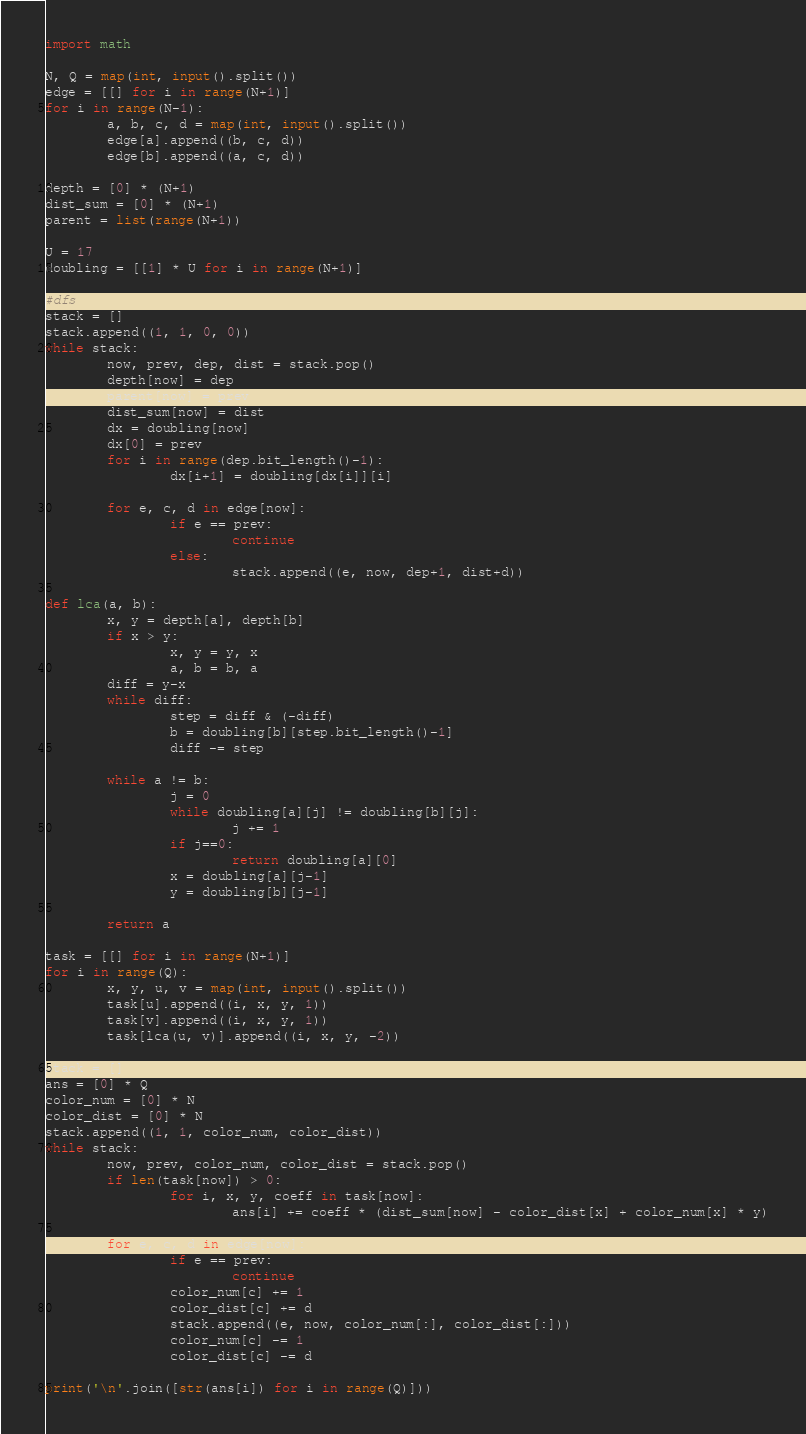Convert code to text. <code><loc_0><loc_0><loc_500><loc_500><_Python_>import math

N, Q = map(int, input().split())
edge = [[] for i in range(N+1)]
for i in range(N-1):
        a, b, c, d = map(int, input().split())
        edge[a].append((b, c, d))
        edge[b].append((a, c, d))

depth = [0] * (N+1)
dist_sum = [0] * (N+1)
parent = list(range(N+1))

U = 17
doubling = [[1] * U for i in range(N+1)]

#dfs
stack = []
stack.append((1, 1, 0, 0))
while stack:
        now, prev, dep, dist = stack.pop()
        depth[now] = dep
        parent[now] = prev
        dist_sum[now] = dist
        dx = doubling[now]
        dx[0] = prev
        for i in range(dep.bit_length()-1):
                dx[i+1] = doubling[dx[i]][i]
        
        for e, c, d in edge[now]:
                if e == prev:
                        continue
                else:
                        stack.append((e, now, dep+1, dist+d))

def lca(a, b):
        x, y = depth[a], depth[b]
        if x > y:
                x, y = y, x
                a, b = b, a        
        diff = y-x
        while diff:
                step = diff & (-diff)
                b = doubling[b][step.bit_length()-1]
                diff -= step

        while a != b:
                j = 0
                while doubling[a][j] != doubling[b][j]:
                        j += 1
                if j==0:
                        return doubling[a][0]
                x = doubling[a][j-1]
                y = doubling[b][j-1]

        return a

task = [[] for i in range(N+1)]
for i in range(Q):
        x, y, u, v = map(int, input().split())
        task[u].append((i, x, y, 1))
        task[v].append((i, x, y, 1))
        task[lca(u, v)].append((i, x, y, -2))

stack = []
ans = [0] * Q
color_num = [0] * N
color_dist = [0] * N
stack.append((1, 1, color_num, color_dist))
while stack:
        now, prev, color_num, color_dist = stack.pop()
        if len(task[now]) > 0:
                for i, x, y, coeff in task[now]:
                        ans[i] += coeff * (dist_sum[now] - color_dist[x] + color_num[x] * y)
                        
        for e, c, d in edge[now]:
                if e == prev:
                        continue
                color_num[c] += 1
                color_dist[c] += d
                stack.append((e, now, color_num[:], color_dist[:]))
                color_num[c] -= 1
                color_dist[c] -= d

print('\n'.join([str(ans[i]) for i in range(Q)]))

</code> 